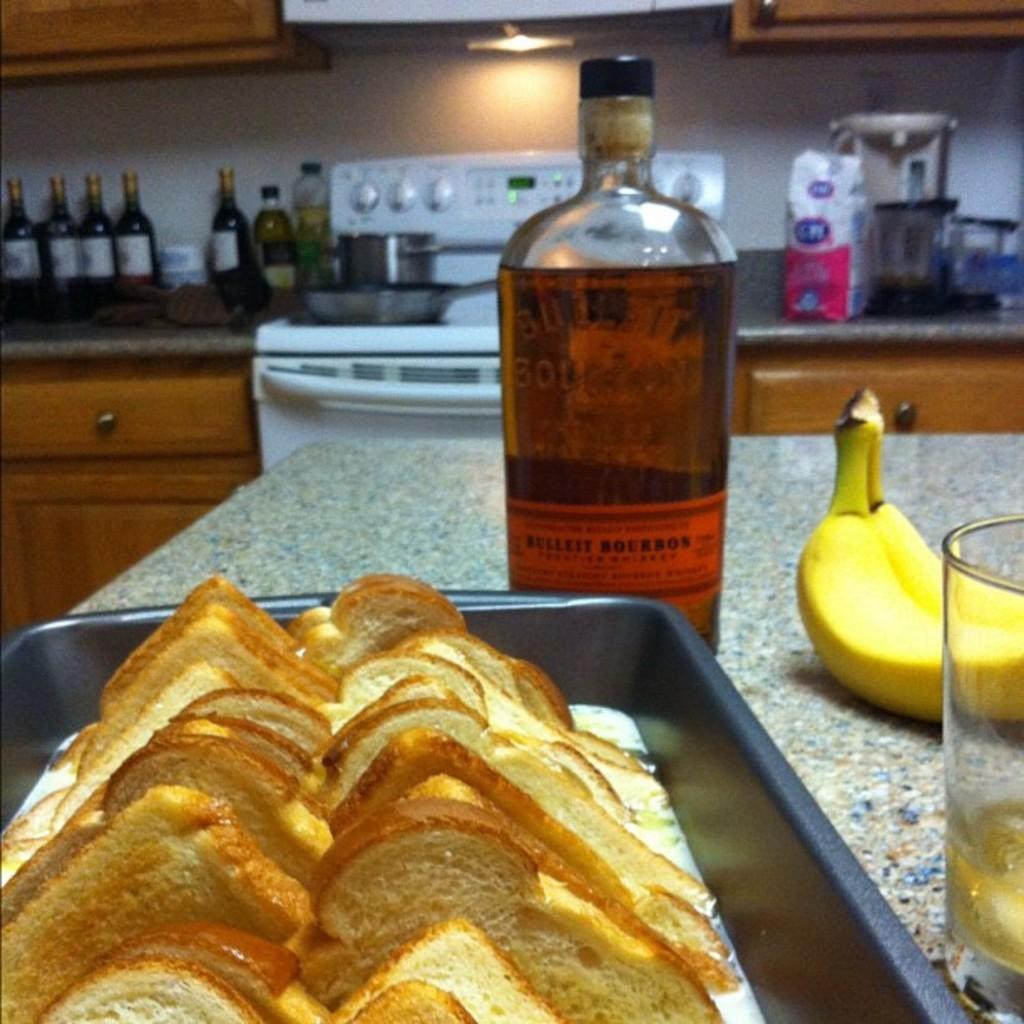Describe this image in one or two sentences. In the image there is a table. On table we can see a wine bottle,banana,glass,bread in a tray. In background we can also see machine,pan,few bottles,wall which is in white color and a light. 